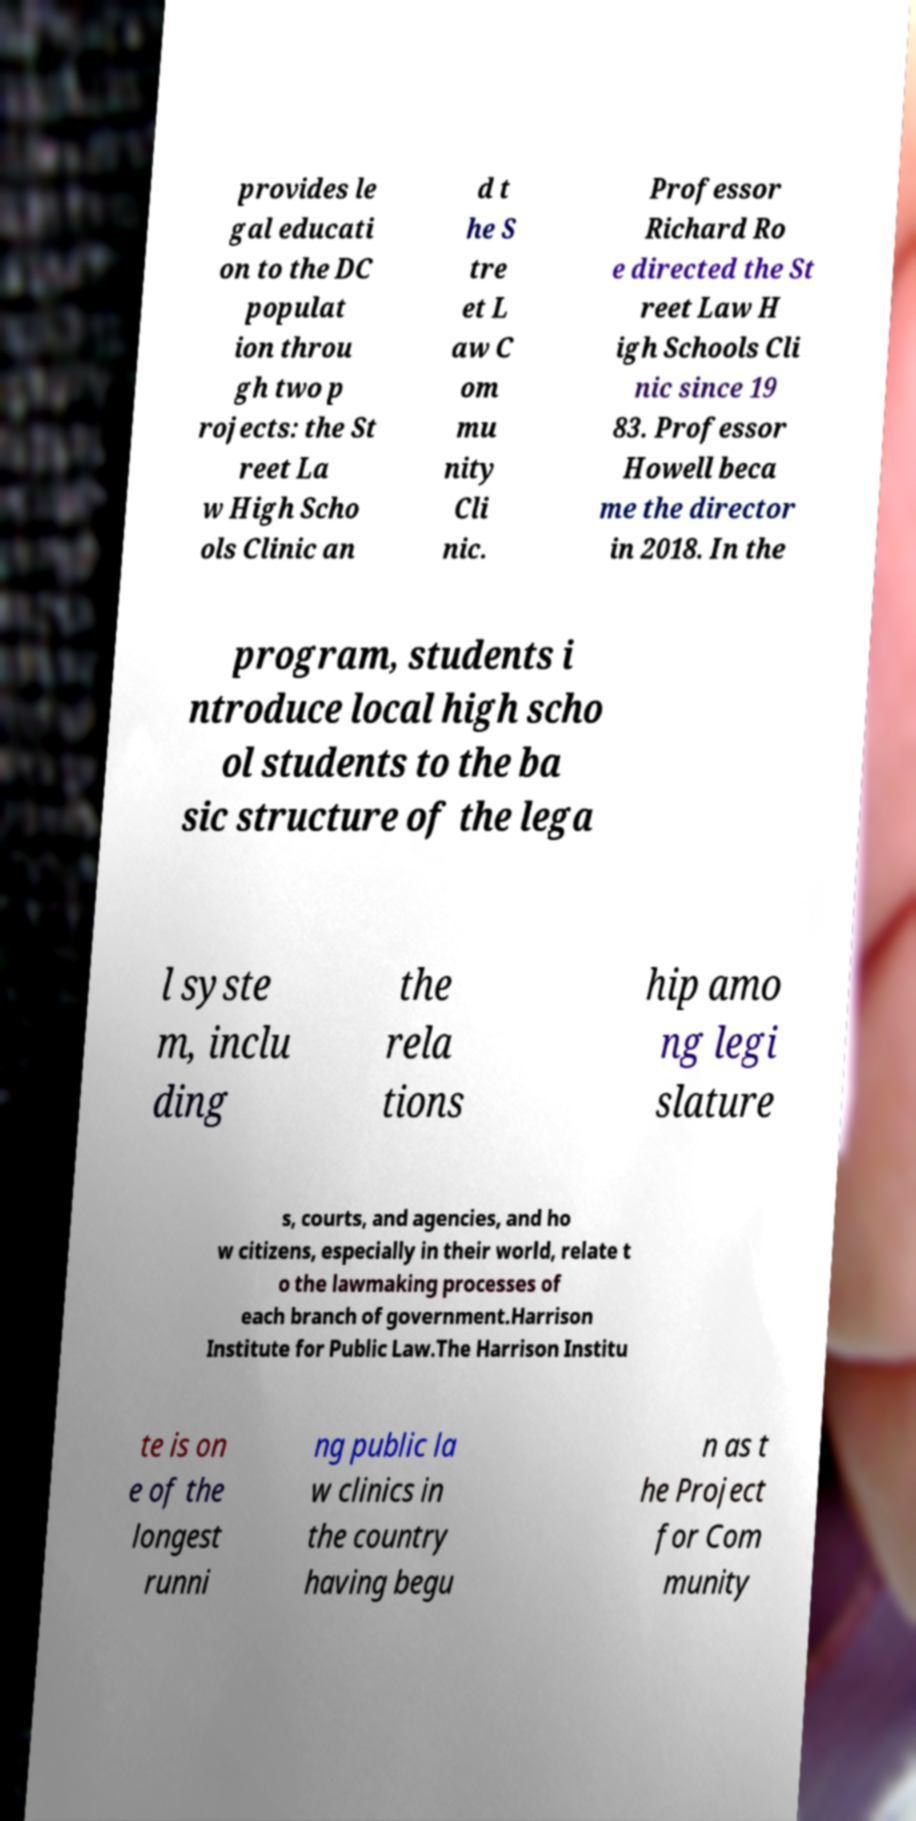I need the written content from this picture converted into text. Can you do that? provides le gal educati on to the DC populat ion throu gh two p rojects: the St reet La w High Scho ols Clinic an d t he S tre et L aw C om mu nity Cli nic. Professor Richard Ro e directed the St reet Law H igh Schools Cli nic since 19 83. Professor Howell beca me the director in 2018. In the program, students i ntroduce local high scho ol students to the ba sic structure of the lega l syste m, inclu ding the rela tions hip amo ng legi slature s, courts, and agencies, and ho w citizens, especially in their world, relate t o the lawmaking processes of each branch of government.Harrison Institute for Public Law.The Harrison Institu te is on e of the longest runni ng public la w clinics in the country having begu n as t he Project for Com munity 